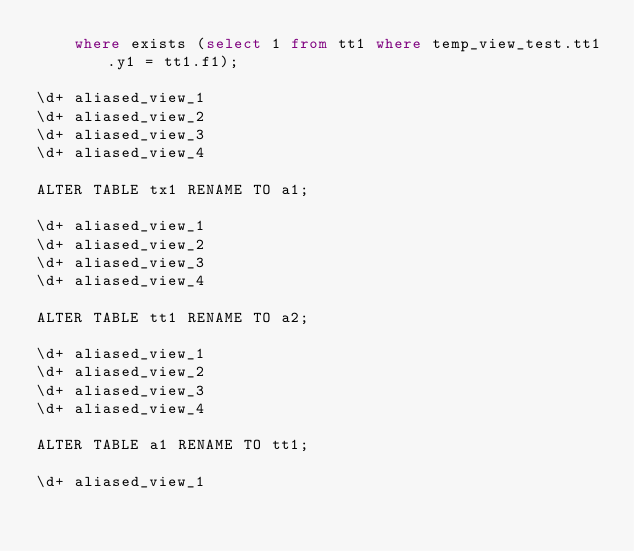<code> <loc_0><loc_0><loc_500><loc_500><_SQL_>    where exists (select 1 from tt1 where temp_view_test.tt1.y1 = tt1.f1);

\d+ aliased_view_1
\d+ aliased_view_2
\d+ aliased_view_3
\d+ aliased_view_4

ALTER TABLE tx1 RENAME TO a1;

\d+ aliased_view_1
\d+ aliased_view_2
\d+ aliased_view_3
\d+ aliased_view_4

ALTER TABLE tt1 RENAME TO a2;

\d+ aliased_view_1
\d+ aliased_view_2
\d+ aliased_view_3
\d+ aliased_view_4

ALTER TABLE a1 RENAME TO tt1;

\d+ aliased_view_1</code> 